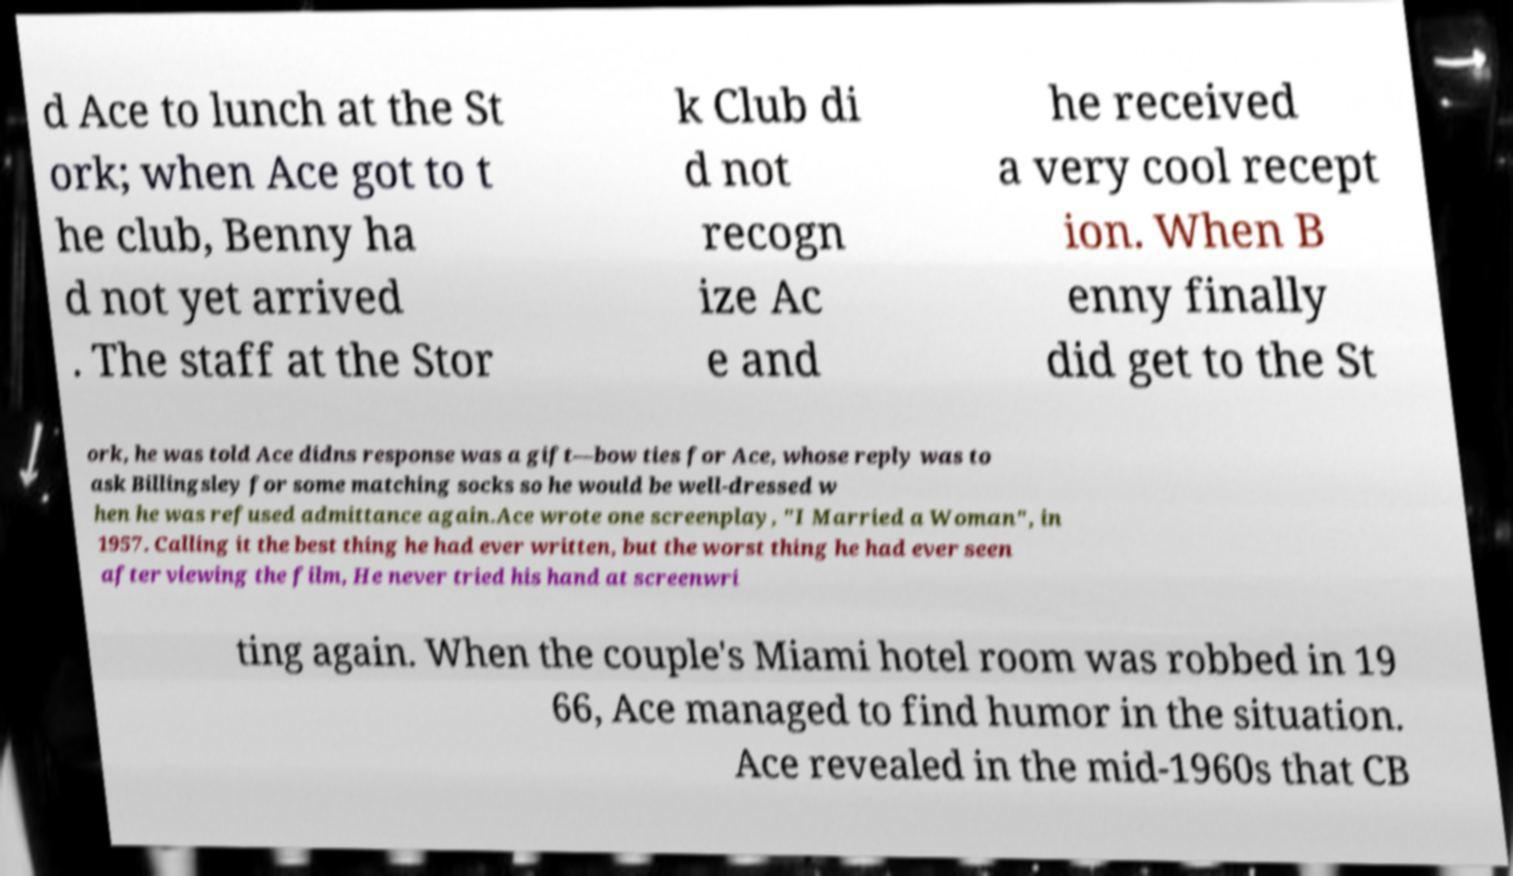Could you assist in decoding the text presented in this image and type it out clearly? d Ace to lunch at the St ork; when Ace got to t he club, Benny ha d not yet arrived . The staff at the Stor k Club di d not recogn ize Ac e and he received a very cool recept ion. When B enny finally did get to the St ork, he was told Ace didns response was a gift—bow ties for Ace, whose reply was to ask Billingsley for some matching socks so he would be well-dressed w hen he was refused admittance again.Ace wrote one screenplay, "I Married a Woman", in 1957. Calling it the best thing he had ever written, but the worst thing he had ever seen after viewing the film, He never tried his hand at screenwri ting again. When the couple's Miami hotel room was robbed in 19 66, Ace managed to find humor in the situation. Ace revealed in the mid-1960s that CB 